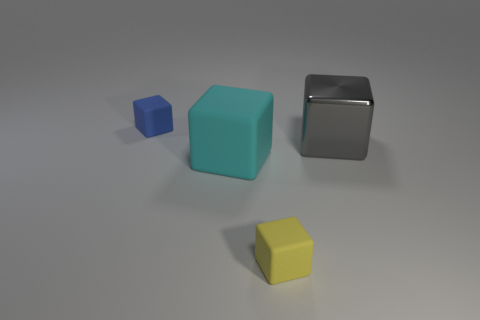What is the material of the blue thing?
Give a very brief answer. Rubber. There is a object that is on the right side of the yellow object; what size is it?
Provide a short and direct response. Large. Are there any other things that are the same color as the metallic block?
Offer a terse response. No. There is a small rubber thing that is on the right side of the small matte thing behind the yellow block; are there any rubber cubes that are behind it?
Offer a very short reply. Yes. How many cylinders are small blue matte things or small rubber things?
Your response must be concise. 0. What is the shape of the small object that is in front of the rubber thing behind the big shiny cube?
Provide a short and direct response. Cube. What is the size of the cyan matte cube that is in front of the big cube right of the small block in front of the metal object?
Offer a terse response. Large. Does the gray cube have the same size as the yellow matte cube?
Your response must be concise. No. What number of objects are small yellow rubber objects or large shiny cubes?
Keep it short and to the point. 2. How big is the metal object right of the small block that is left of the yellow rubber object?
Provide a short and direct response. Large. 